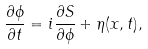<formula> <loc_0><loc_0><loc_500><loc_500>\frac { \partial \phi } { \partial t } = i \frac { \partial S } { \partial \phi } + \eta ( x , t ) ,</formula> 